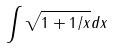Convert formula to latex. <formula><loc_0><loc_0><loc_500><loc_500>\int \sqrt { 1 + 1 / x } d x</formula> 